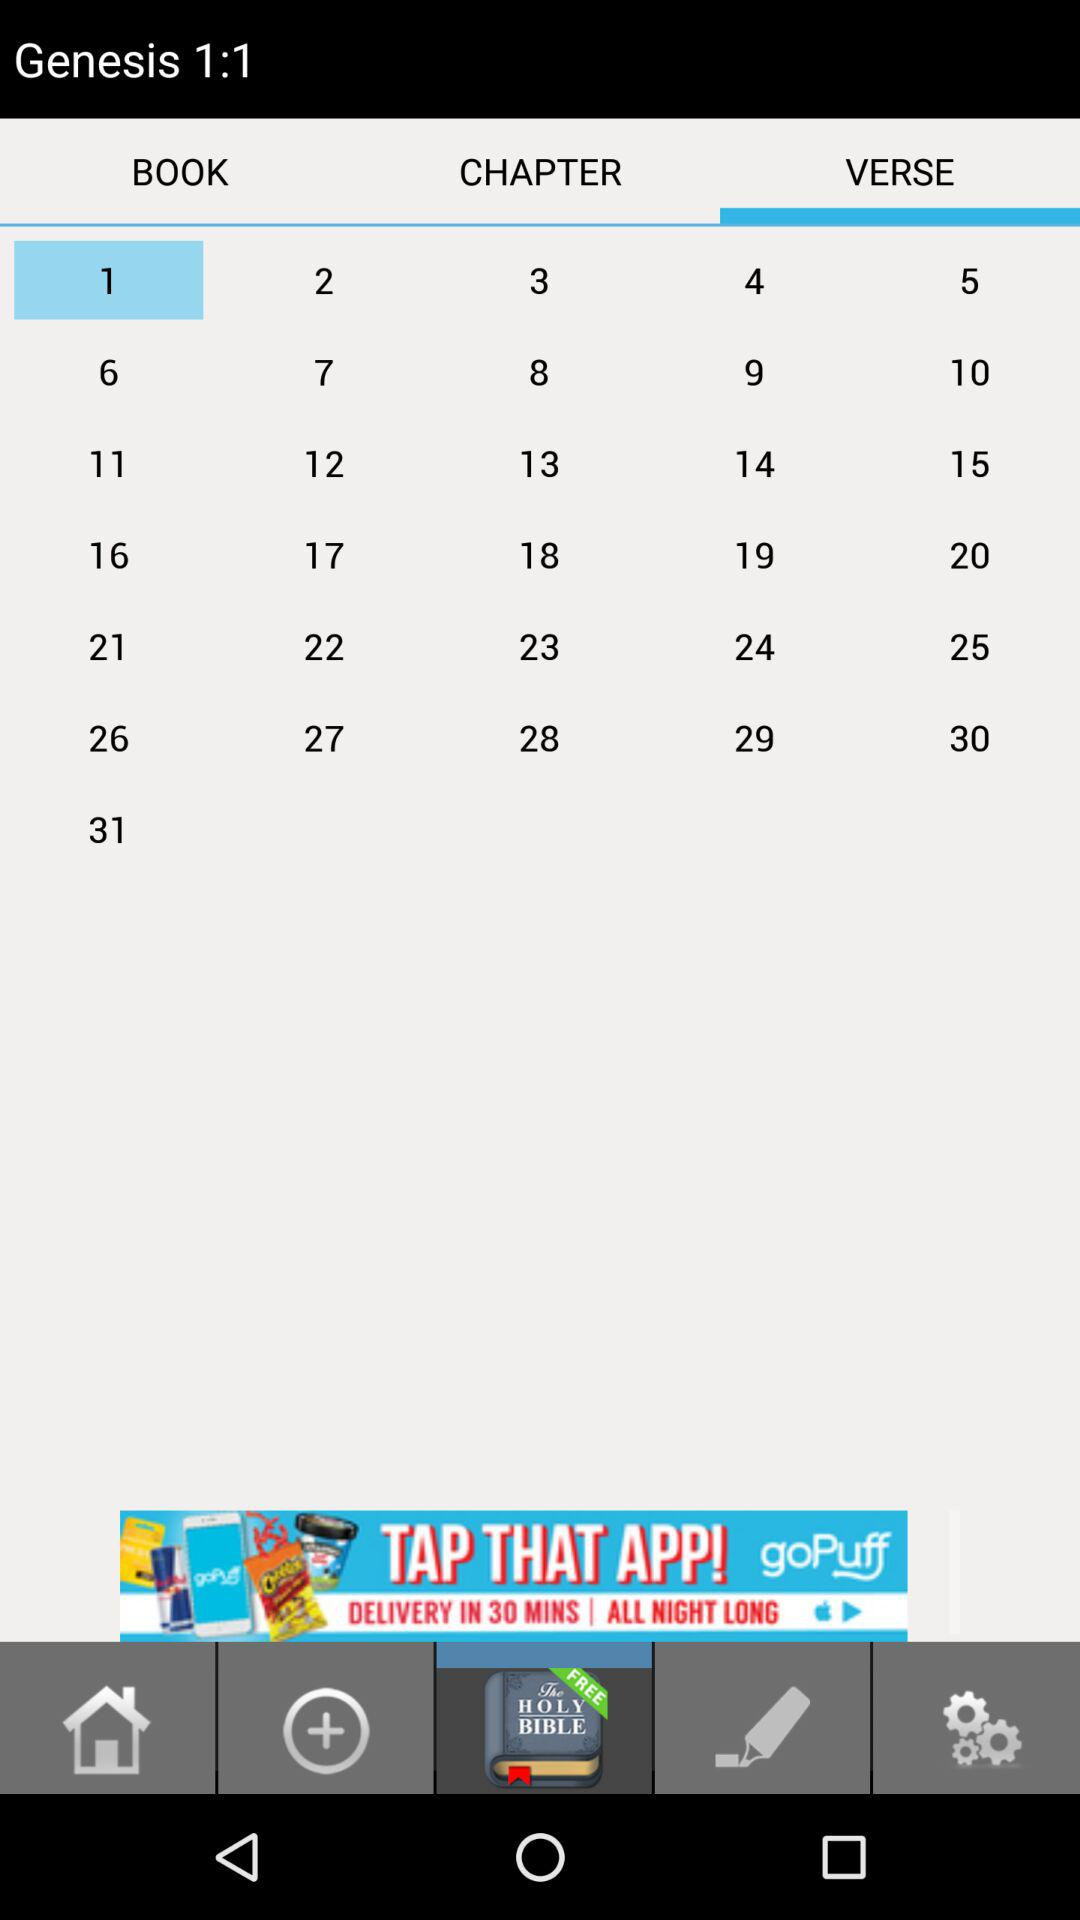Which tab is selected? The selected tabs are "VERSE" and "Bible KJV". 